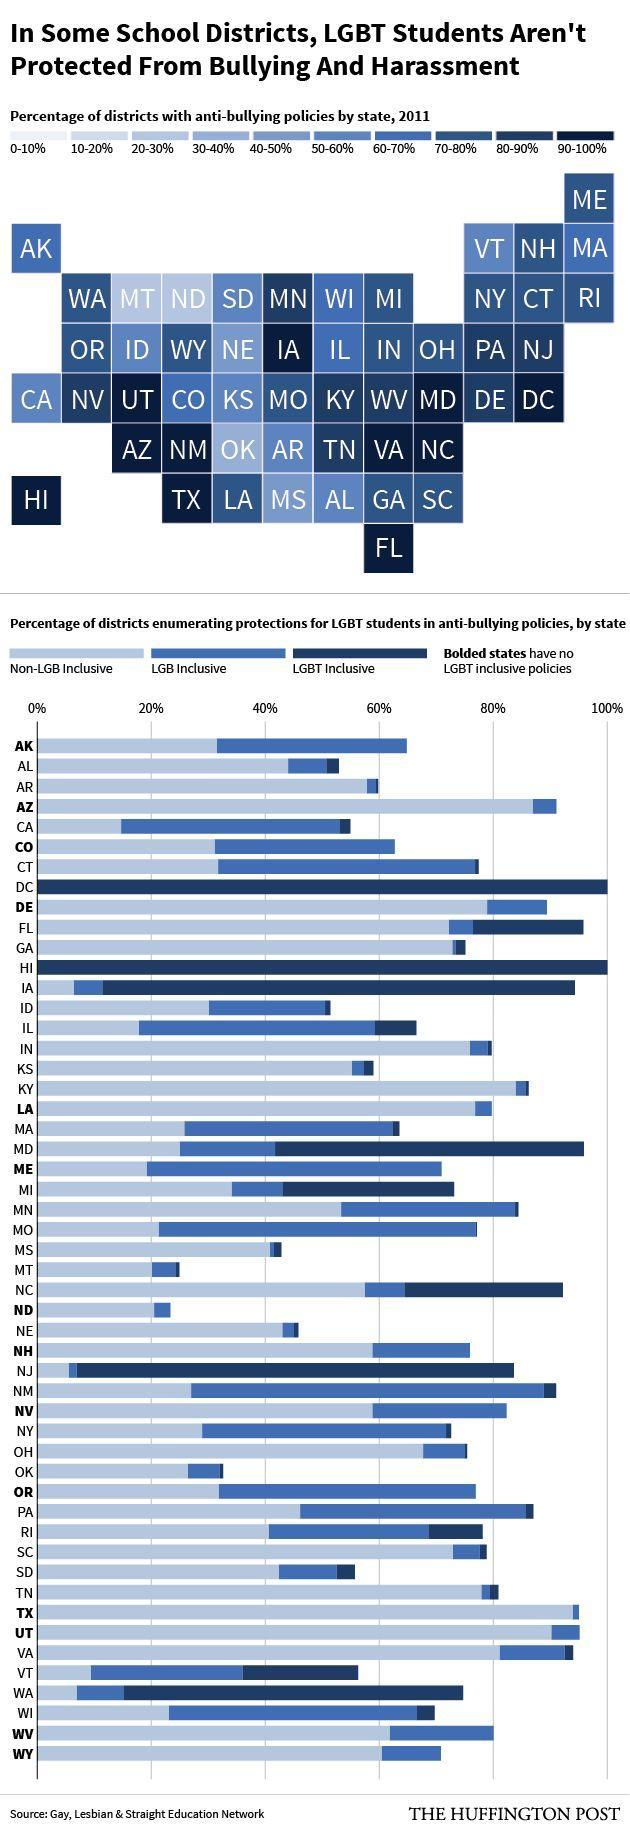How many school districts do not have LGBT inclusive policies?
Answer the question with a short phrase. 14 How many school districts have close 90-100% of anti-bullying policies by state? 11 